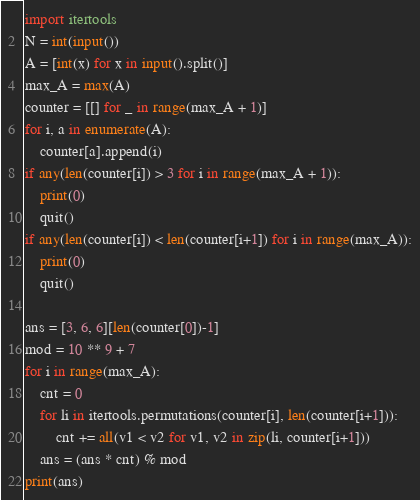Convert code to text. <code><loc_0><loc_0><loc_500><loc_500><_Python_>import itertools
N = int(input())
A = [int(x) for x in input().split()]
max_A = max(A)
counter = [[] for _ in range(max_A + 1)]
for i, a in enumerate(A):
    counter[a].append(i)
if any(len(counter[i]) > 3 for i in range(max_A + 1)):
    print(0)
    quit()
if any(len(counter[i]) < len(counter[i+1]) for i in range(max_A)):
    print(0)
    quit()

ans = [3, 6, 6][len(counter[0])-1]
mod = 10 ** 9 + 7
for i in range(max_A):
    cnt = 0
    for li in itertools.permutations(counter[i], len(counter[i+1])):
        cnt += all(v1 < v2 for v1, v2 in zip(li, counter[i+1]))
    ans = (ans * cnt) % mod
print(ans)
</code> 